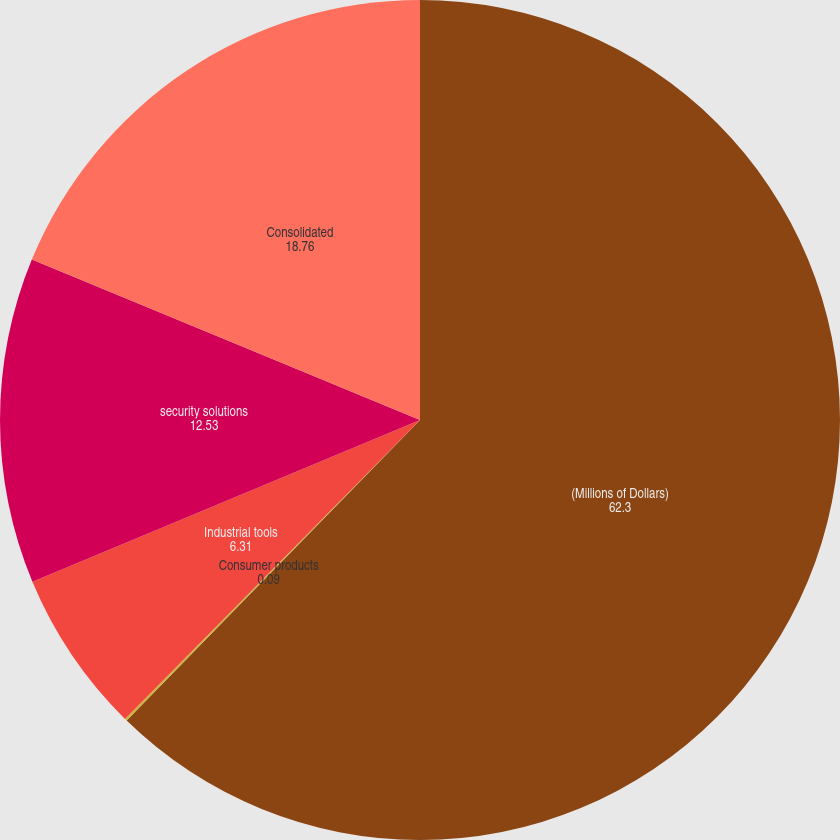<chart> <loc_0><loc_0><loc_500><loc_500><pie_chart><fcel>(Millions of Dollars)<fcel>Consumer products<fcel>Industrial tools<fcel>security solutions<fcel>Consolidated<nl><fcel>62.3%<fcel>0.09%<fcel>6.31%<fcel>12.53%<fcel>18.76%<nl></chart> 